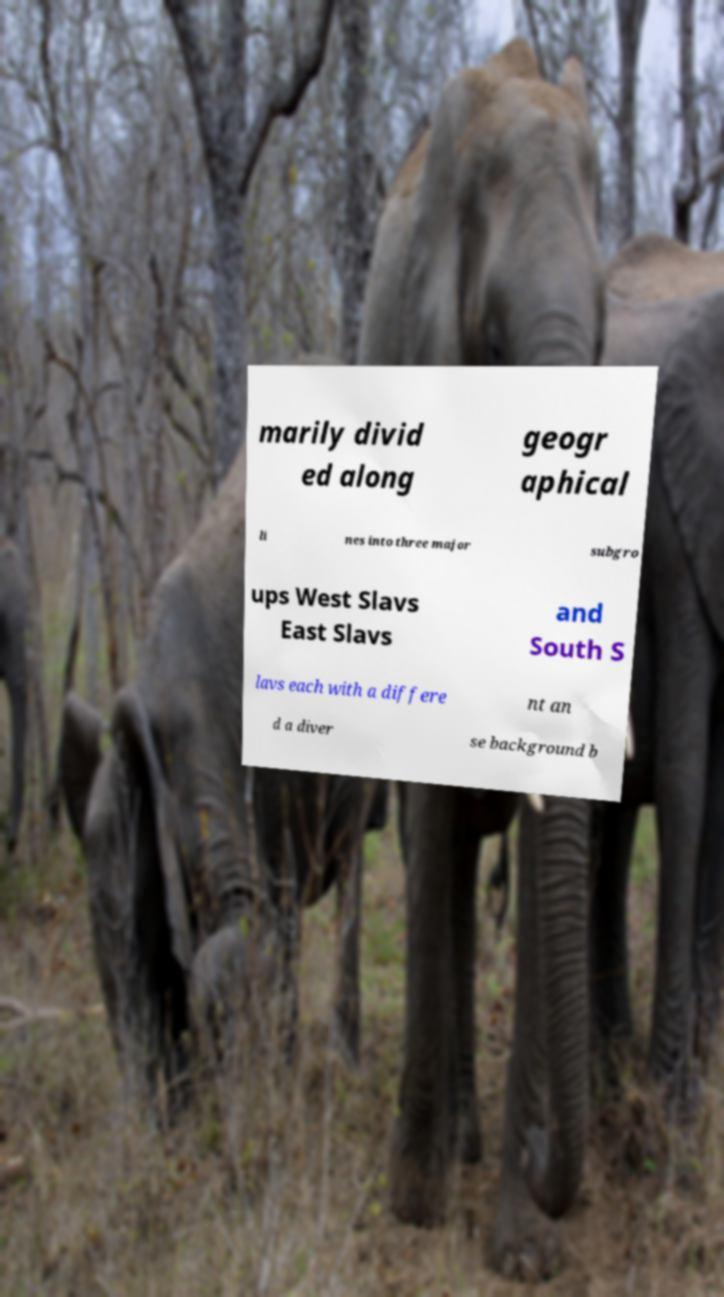Please read and relay the text visible in this image. What does it say? marily divid ed along geogr aphical li nes into three major subgro ups West Slavs East Slavs and South S lavs each with a differe nt an d a diver se background b 